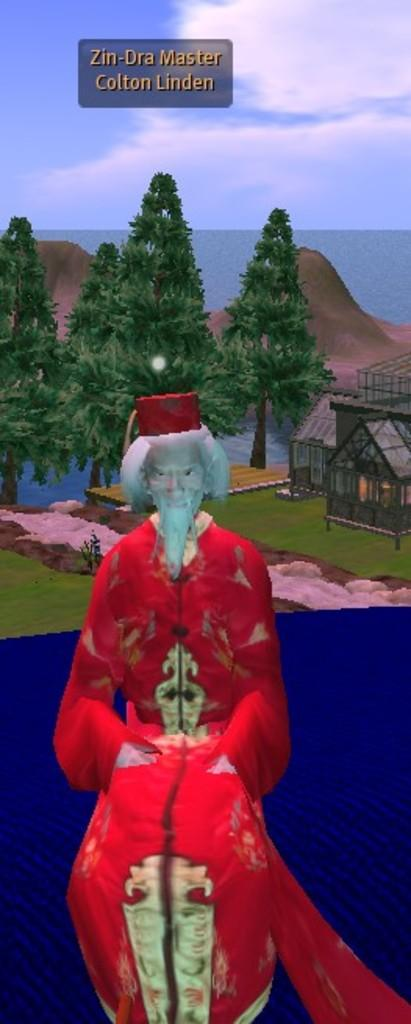What type of image is being described? The image is an animated picture. Can you describe the person in the image? There is a person in the image. What type of natural environment is depicted in the image? There are trees and water in the image, suggesting a natural setting. What is visible at the top of the image? The sky is visible at the top of the image. Are there any words or letters in the image? Yes, there is some text in the image. What type of base is the person standing on in the image? There is no specific base mentioned in the image, as it is an animated picture and the person's surroundings are not clearly defined. 